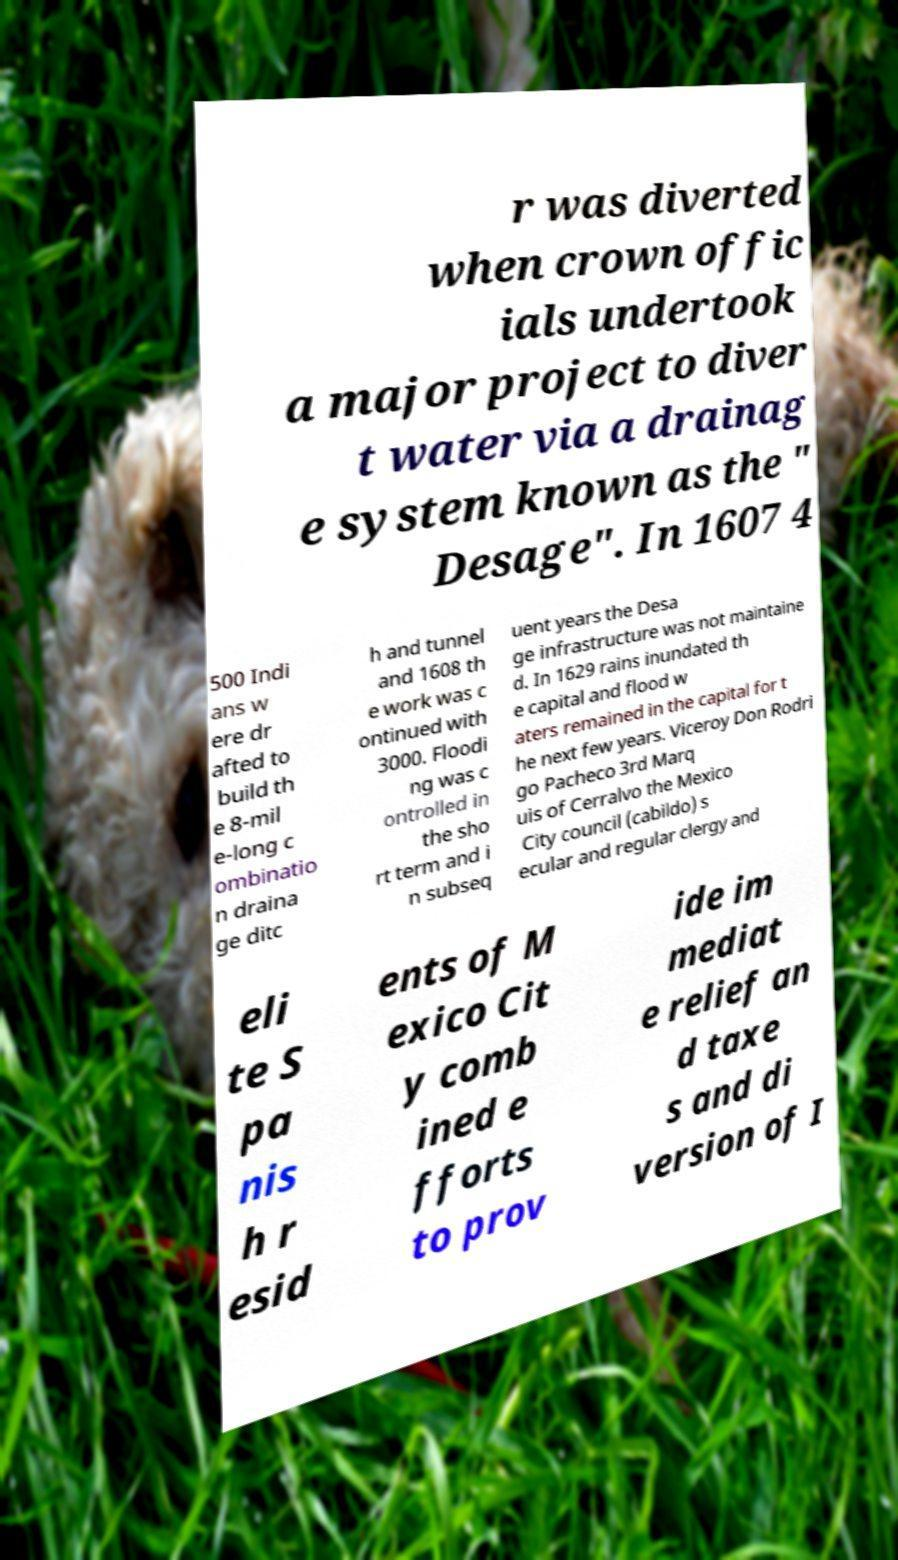Could you assist in decoding the text presented in this image and type it out clearly? r was diverted when crown offic ials undertook a major project to diver t water via a drainag e system known as the " Desage". In 1607 4 500 Indi ans w ere dr afted to build th e 8-mil e-long c ombinatio n draina ge ditc h and tunnel and 1608 th e work was c ontinued with 3000. Floodi ng was c ontrolled in the sho rt term and i n subseq uent years the Desa ge infrastructure was not maintaine d. In 1629 rains inundated th e capital and flood w aters remained in the capital for t he next few years. Viceroy Don Rodri go Pacheco 3rd Marq uis of Cerralvo the Mexico City council (cabildo) s ecular and regular clergy and eli te S pa nis h r esid ents of M exico Cit y comb ined e fforts to prov ide im mediat e relief an d taxe s and di version of I 